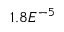<formula> <loc_0><loc_0><loc_500><loc_500>1 . 8 E ^ { - 5 }</formula> 